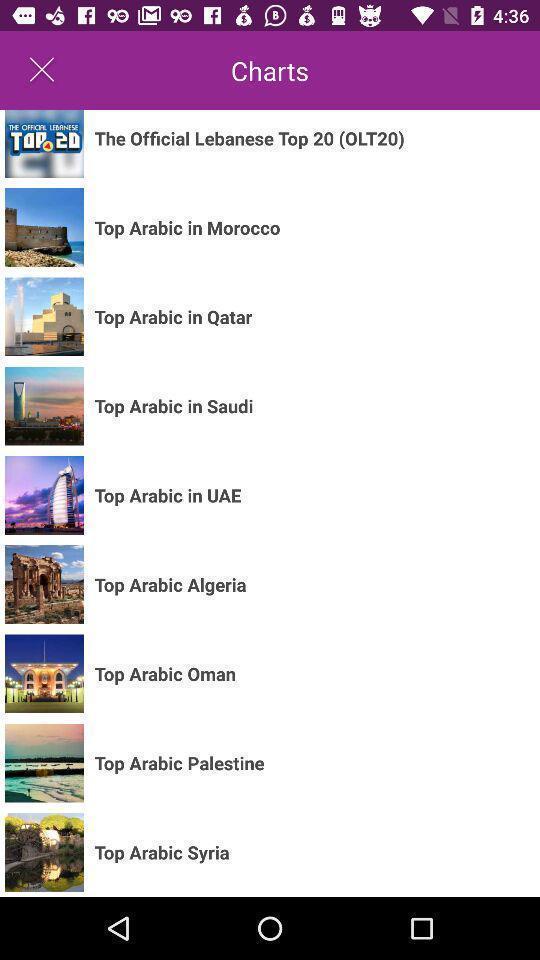Please provide a description for this image. Screen page displaying various places. 